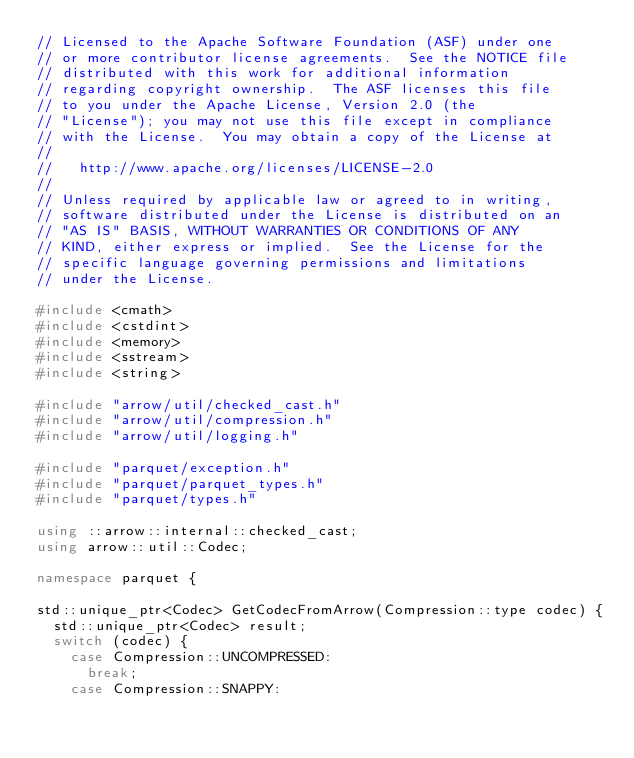<code> <loc_0><loc_0><loc_500><loc_500><_C++_>// Licensed to the Apache Software Foundation (ASF) under one
// or more contributor license agreements.  See the NOTICE file
// distributed with this work for additional information
// regarding copyright ownership.  The ASF licenses this file
// to you under the Apache License, Version 2.0 (the
// "License"); you may not use this file except in compliance
// with the License.  You may obtain a copy of the License at
//
//   http://www.apache.org/licenses/LICENSE-2.0
//
// Unless required by applicable law or agreed to in writing,
// software distributed under the License is distributed on an
// "AS IS" BASIS, WITHOUT WARRANTIES OR CONDITIONS OF ANY
// KIND, either express or implied.  See the License for the
// specific language governing permissions and limitations
// under the License.

#include <cmath>
#include <cstdint>
#include <memory>
#include <sstream>
#include <string>

#include "arrow/util/checked_cast.h"
#include "arrow/util/compression.h"
#include "arrow/util/logging.h"

#include "parquet/exception.h"
#include "parquet/parquet_types.h"
#include "parquet/types.h"

using ::arrow::internal::checked_cast;
using arrow::util::Codec;

namespace parquet {

std::unique_ptr<Codec> GetCodecFromArrow(Compression::type codec) {
  std::unique_ptr<Codec> result;
  switch (codec) {
    case Compression::UNCOMPRESSED:
      break;
    case Compression::SNAPPY:</code> 